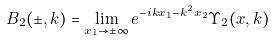Convert formula to latex. <formula><loc_0><loc_0><loc_500><loc_500>B _ { 2 } ( \pm , k ) = \lim _ { x _ { 1 } \rightarrow \pm \infty } e ^ { - i k x _ { 1 } - k ^ { 2 } x _ { 2 } } \Upsilon _ { 2 } ( x , k )</formula> 